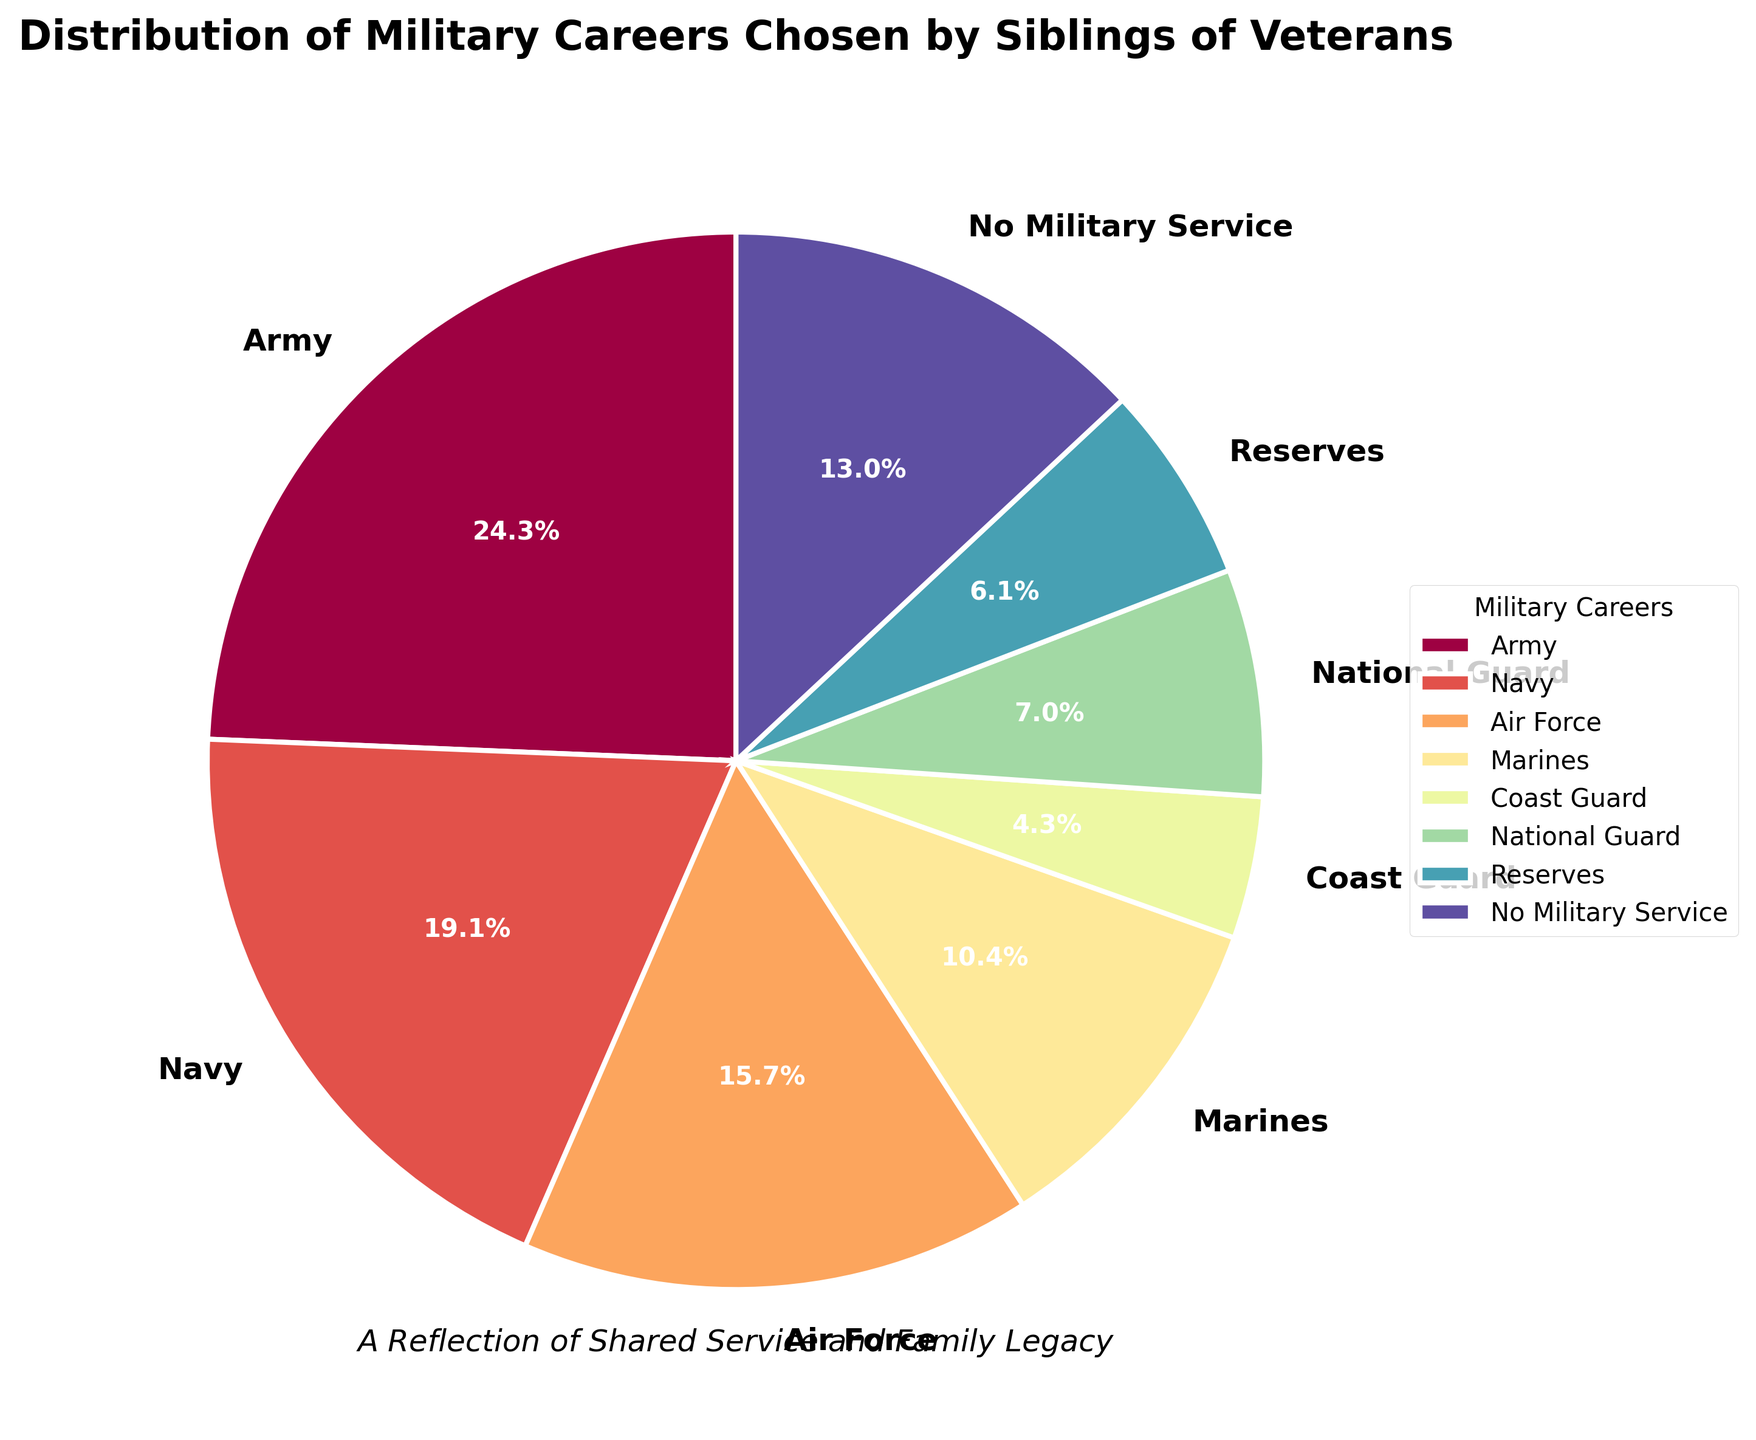Which military career is chosen by the largest percentage of siblings? The Army segment occupies the largest portion of the pie chart and is prominently labeled with 28%.
Answer: Army What is the combined percentage of siblings who chose the Navy and Air Force careers? Sum the percentages for Navy (22%) and Air Force (18%): 22 + 18 = 40%.
Answer: 40% How does the percentage of siblings who chose the Coast Guard compare to those who chose the Marines? The Coast Guard has a smaller percentage (5%) compared to the Marines (12%). 5 is less than 12.
Answer: Coast Guard is less Which two military careers have the lowest percentages? By examining the pie chart, the smallest slices correspond to the Coast Guard (5%) and Reserves (7%).
Answer: Coast Guard and Reserves What is the difference in percentage between siblings who chose National Guard and those with no military service? The percentage for National Guard (8%) subtracted from No Military Service (15%) gives 15 - 8 = 7%.
Answer: 7% Which segment has more siblings: those in the Reserves or those with No Military Service? The No Military Service segment has a larger percentage (15%) compared to the Reserves (7%).
Answer: No Military Service How does the percentage of Air Force compare with that of the Marines and National Guard combined? Combine the Marines (12%) and National Guard (8%) to get 12 + 8 = 20%. The Air Force is 18%, which is less than 20%.
Answer: Air Force is less What percentage of siblings chose either the Army, Navy, or Air Force? Sum the percentages for Army (28%), Navy (22%), and Air Force (18%): 28 + 22 + 18 = 68%.
Answer: 68% What is the visual attribute that distinguishes the Coast Guard segment from the Reserves segment? The Coast Guard segment is smaller in size and has a different color compared to the larger and differently colored Reserves segment.
Answer: Size and color If you consider the Army and Navy together, how does their combined percentage compare to the total percentage of all other careers? The combined percentage of Army (28%) and Navy (22%) is 50%. The total for all other careers and No Military Service is 100 - 50 = 50%. Both combined percentages are equal.
Answer: Equal 